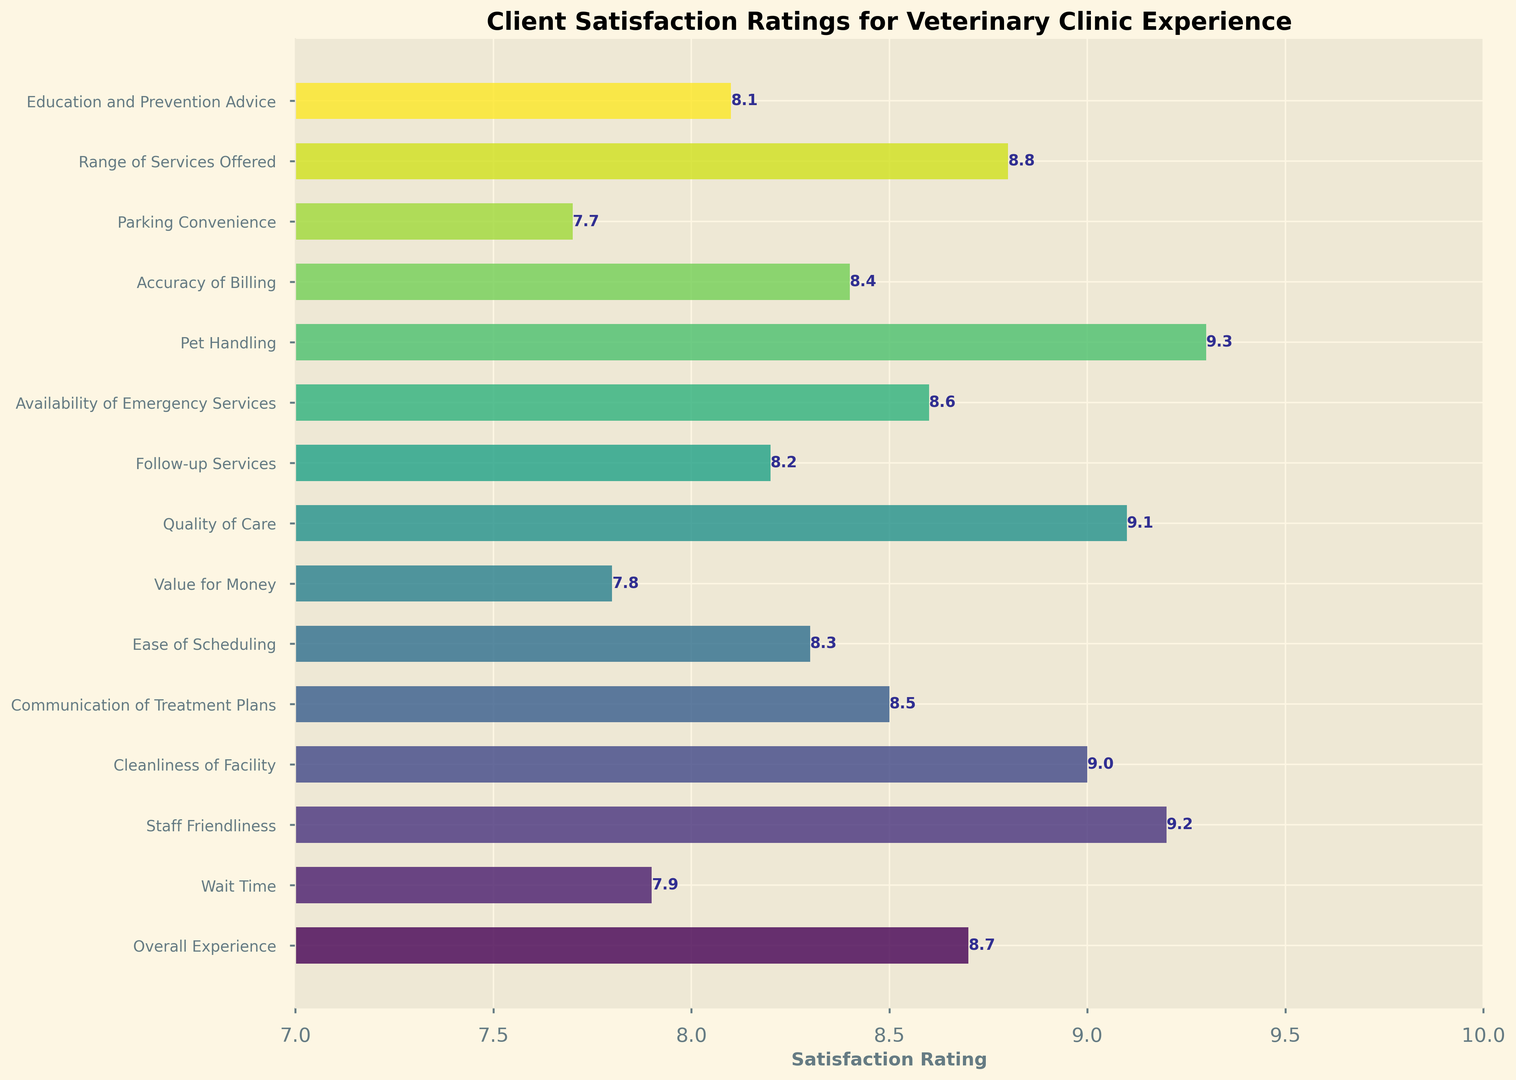Which aspect has the highest satisfaction rating? The highest bar on the chart represents the aspect with the highest satisfaction rating. The bar for "Pet Handling" stands out as the tallest.
Answer: Pet Handling Which aspect has the lowest satisfaction rating? The smallest bar on the chart indicates the aspect with the lowest satisfaction rating. The bar for "Parking Convenience" is the shortest.
Answer: Parking Convenience Are there any aspects with a rating higher than 9.0? If so, which ones? To find aspects with ratings higher than 9.0, look for bars extending beyond the 9.0 mark on the x-axis. "Staff Friendliness," "Cleanliness of Facility," "Quality of Care," and "Pet Handling" are all higher than 9.0.
Answer: Staff Friendliness, Cleanliness of Facility, Quality of Care, Pet Handling What is the average satisfaction rating across all aspects? Summing up all ratings: 8.7 + 7.9 + 9.2 + 9.0 + 8.5 + 8.3 + 7.8 + 9.1 + 8.2 + 8.6 + 9.3 + 8.4 + 7.7 + 8.8 + 8.1 = 129.6. There are 15 aspects, so the average rating is 129.6 / 15 = 8.64.
Answer: 8.6 How does the satisfaction rating for "Overall Experience" compare to "Wait Time"? The bar for "Overall Experience" is at 8.7, and the bar for "Wait Time" is at 7.9. Therefore, "Overall Experience" has a higher rating than "Wait Time."
Answer: Overall Experience is higher What is the combined rating of "Ease of Scheduling" and "Follow-up Services"? Adding the ratings for "Ease of Scheduling" (8.3) and "Follow-up Services" (8.2): 8.3 + 8.2 = 16.5.
Answer: 16.5 Is the rating for "Value for Money" higher or lower than "Education and Prevention Advice"? Compare the heights of the two bars. "Value for Money" has a rating of 7.8, while "Education and Prevention Advice" is 8.1. Thus, "Value for Money" is lower.
Answer: Lower How many aspects have a satisfaction rating of 8.5 or higher? Count the bars that extend to 8.5 or higher on the x-axis. The aspects are "Overall Experience," "Staff Friendliness," "Cleanliness of Facility," "Communication of Treatment Plans," "Quality of Care," "Availability of Emergency Services," "Pet Handling," "Accuracy of Billing," "Range of Services Offered," and "Education and Prevention Advice." The total count is 10.
Answer: 10 What is the difference between the ratings for "Quality of Care" and "Accuracy of Billing"? Subtract the rating of "Accuracy of Billing" (8.4) from the rating of "Quality of Care" (9.1): 9.1 - 8.4 = 0.7.
Answer: 0.7 Is "Parking Convenience" rated higher than 8.0? Check if the bar for "Parking Convenience" extends past 8.0. The rating is 7.7, so it does not.
Answer: No 